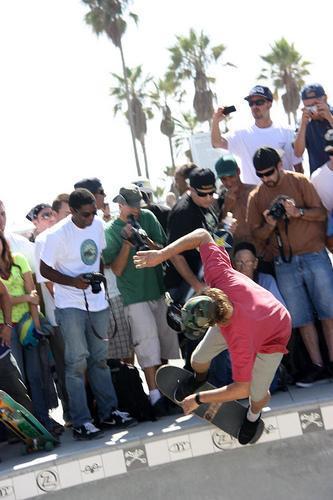How many people are actively skateboarding in this photo?
Give a very brief answer. 1. How many skateboards are visible?
Give a very brief answer. 2. How many cameras are out?
Give a very brief answer. 5. How many people are there?
Give a very brief answer. 10. 